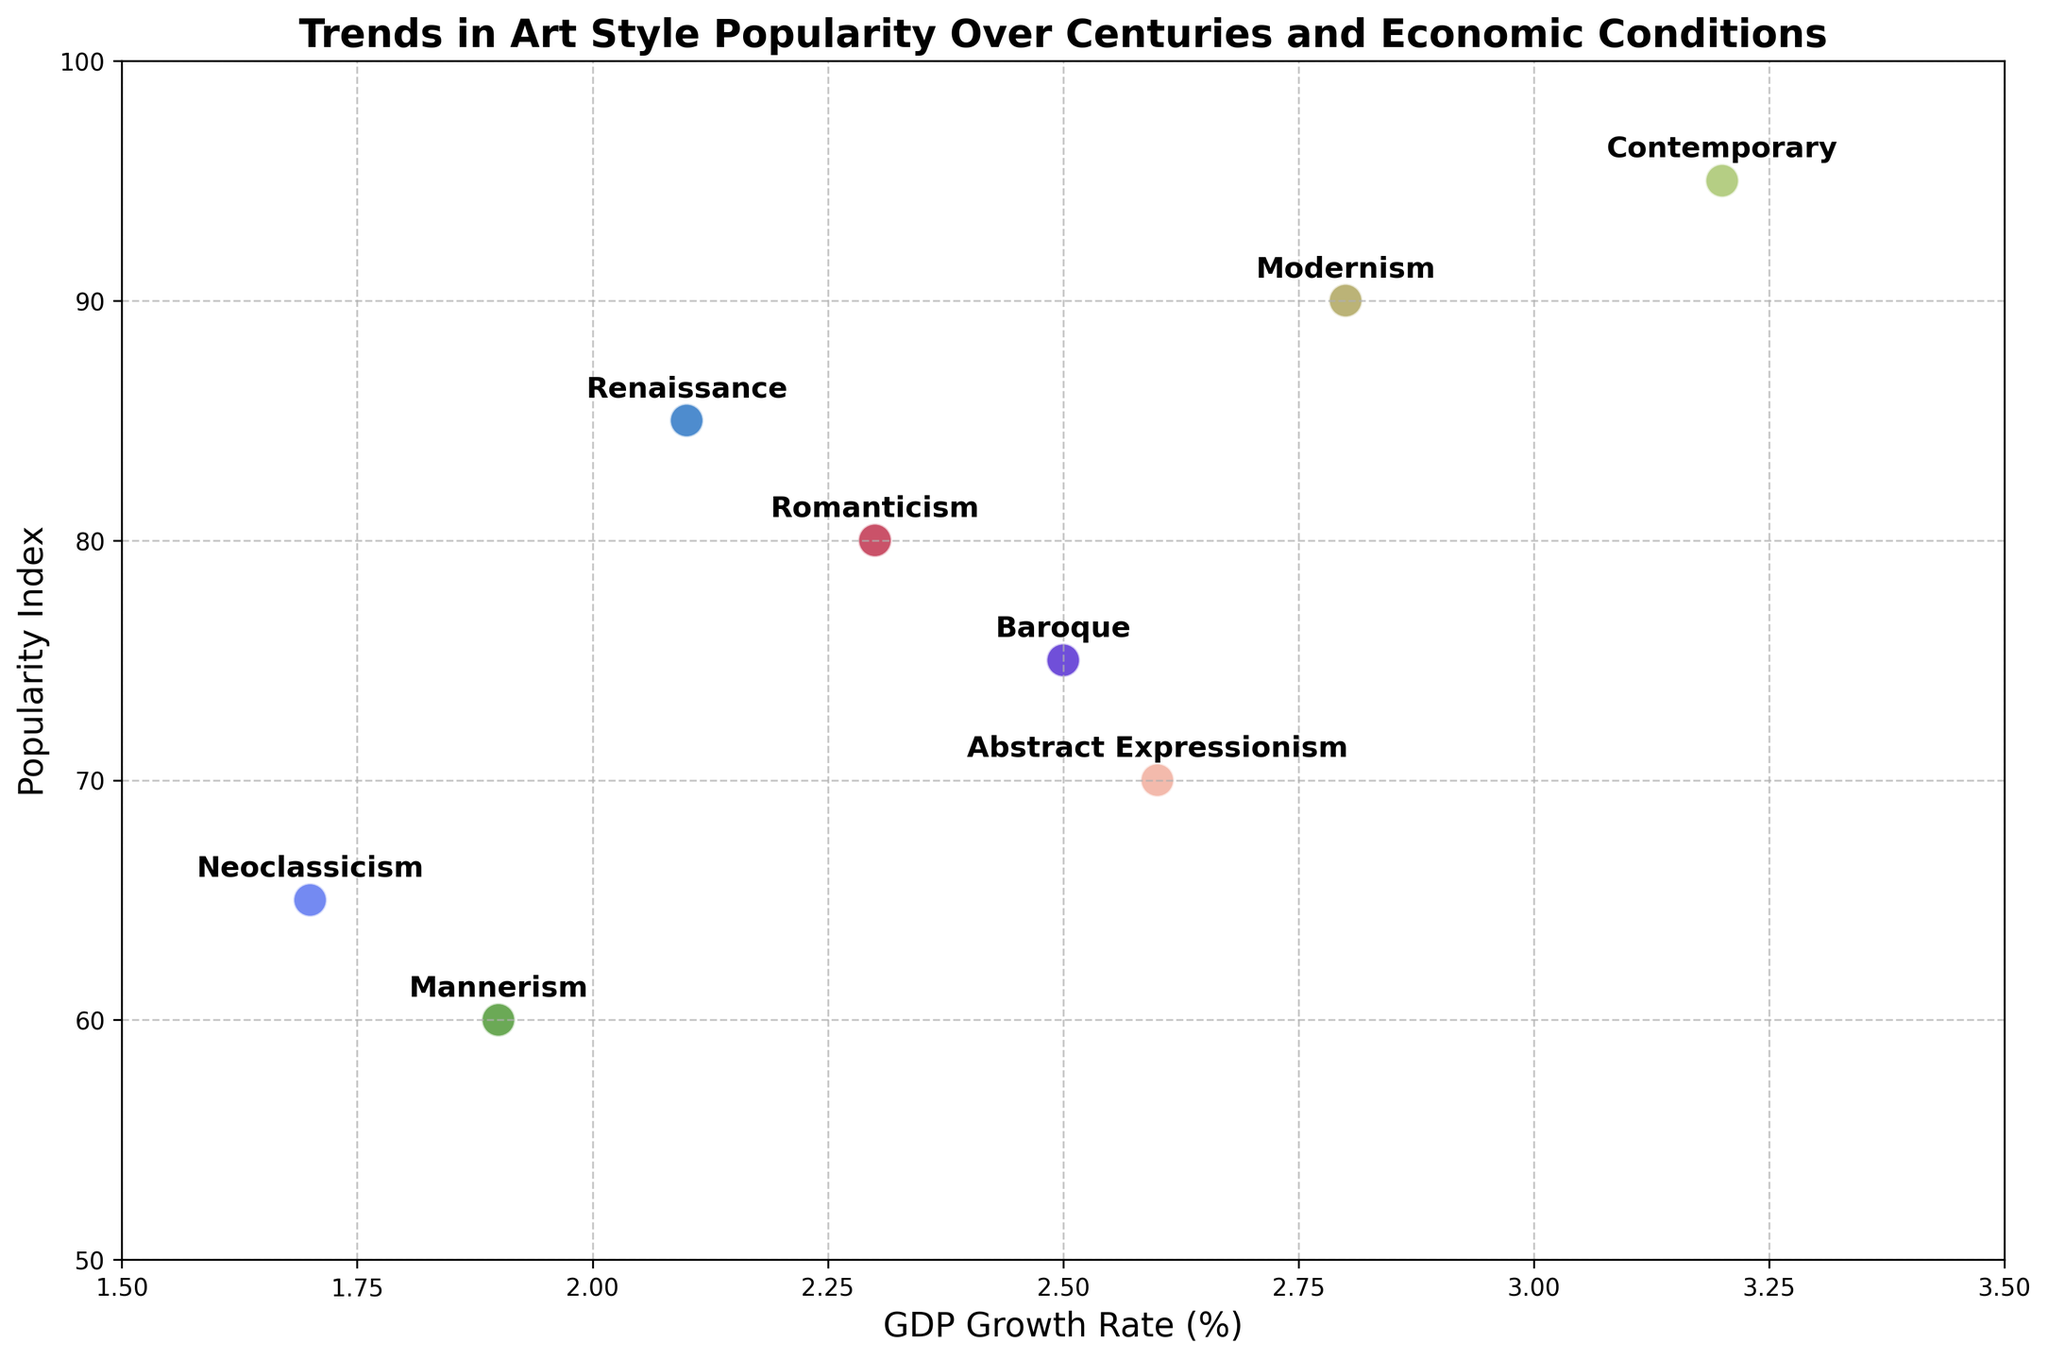What art style has the highest popularity index? Look at the y-axis (popularity index) and identify which point is the highest. The highest point corresponds to the 'Contemporary' art style with a popularity index of 95.
Answer: Contemporary What is the average GDP growth rate for art styles with a popularity index above 80? Identify art styles with a popularity index above 80: Renaissance (2.1), Romanticism (2.3), Modernism (2.8), Contemporary (3.2). Calculate the average GDP growth rate: (2.1 + 2.3 + 2.8 + 3.2) / 4 = 10.4 / 4 = 2.6.
Answer: 2.6 Which art style is associated with the lowest GDP growth rate? Look at the x-axis (GDP growth rate) and identify which point is the furthest left. The furthest left point corresponds to 'Neoclassicism' with a GDP growth rate of 1.7%.
Answer: Neoclassicism Compare the popularity index of Modernism and Baroque. Which one is higher and by how much? Identify the popularity indices of Modernism (90) and Baroque (75). Subtract the smaller value from the larger value: 90 - 75 = 15. Modernism has a higher popularity index by 15.
Answer: Modernism by 15 How many art styles have a popularity index lower than 70? Identify art styles with a popularity index lower than 70: Mannerism (60), Neoclassicism (65), Abstract Expressionism (70). There are three art styles.
Answer: 3 Which time period corresponds to the highest GDP growth rate, and what is the value? Look at the x-axis (GDP growth rate) and identify which point is the furthest right. The furthest right point corresponds to the 'Contemporary' art style with a GDP growth rate of 3.2%. The time period is 2001-2022.
Answer: 2001-2022; 3.2 What is the difference in popularity index between Renaissance and Neoclassicism? Identify the popularity indices of Renaissance (85) and Neoclassicism (65). Subtract the smaller value from the larger value: 85 - 65 = 20.
Answer: 20 How does the popularity index of Abstract Expressionism compare to Romanticism? Identify the popularity indices of Abstract Expressionism (70) and Romanticism (80). Compare the two values. Abstract Expressionism is lower by 10.
Answer: Lower by 10 Considering all art styles, what is the range of GDP growth rates visualized in the plot? Identify the minimum (Neoclassicism, 1.7) and maximum (Contemporary, 3.2) GDP growth rates. Subtract the smaller value from the larger value: 3.2 - 1.7 = 1.5. The range is 1.5.
Answer: 1.5 Which art style from the 19th century is shown in the plot, and what is its popularity index? Identify the time period for the 19th century (1800-1899). The corresponding art style is 'Romanticism' with a popularity index of 80.
Answer: Romanticism; 80 